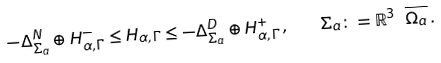<formula> <loc_0><loc_0><loc_500><loc_500>- \Delta _ { \Sigma _ { a } } ^ { N } \oplus H _ { \alpha , \Gamma } ^ { - } \leq H _ { \alpha , \Gamma } \leq - \Delta _ { \Sigma _ { a } } ^ { D } \oplus H _ { \alpha , \Gamma } ^ { + } \, , \quad \Sigma _ { a } \colon = \mathbb { R } ^ { 3 } \ \overline { \Omega _ { a } } \, .</formula> 